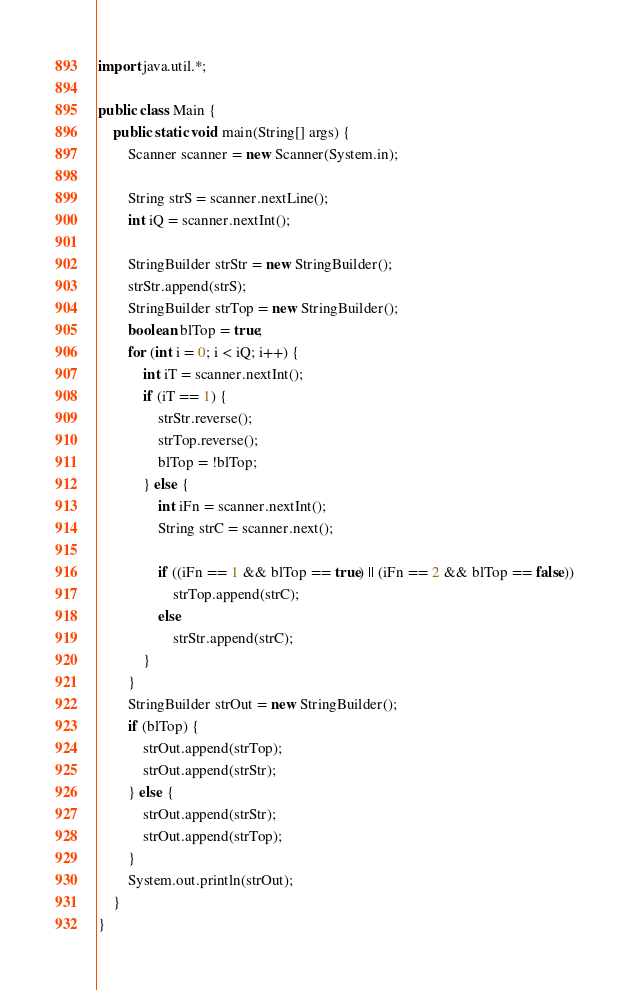<code> <loc_0><loc_0><loc_500><loc_500><_Java_>import java.util.*;
 
public class Main {
    public static void main(String[] args) {
        Scanner scanner = new Scanner(System.in);
 
        String strS = scanner.nextLine();
        int iQ = scanner.nextInt();
        
        StringBuilder strStr = new StringBuilder();
        strStr.append(strS);
        StringBuilder strTop = new StringBuilder();
        boolean blTop = true;
        for (int i = 0; i < iQ; i++) {
            int iT = scanner.nextInt();
            if (iT == 1) {
                strStr.reverse();
                strTop.reverse(); 
                blTop = !blTop;
            } else {
                int iFn = scanner.nextInt();
                String strC = scanner.next();

                if ((iFn == 1 && blTop == true) || (iFn == 2 && blTop == false))
                    strTop.append(strC);
                else 
                    strStr.append(strC); 
            }
        }
        StringBuilder strOut = new StringBuilder();
        if (blTop) {
            strOut.append(strTop);
            strOut.append(strStr);
        } else {
            strOut.append(strStr);
            strOut.append(strTop);
        }
        System.out.println(strOut);  
    }
}
</code> 